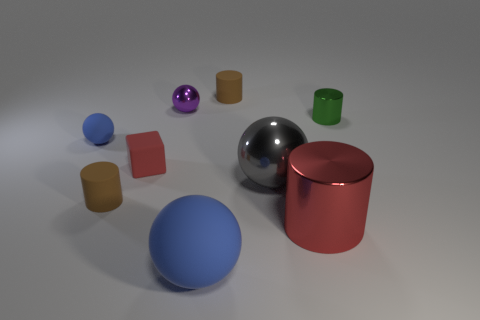Subtract 1 spheres. How many spheres are left? 3 Add 1 tiny yellow rubber spheres. How many objects exist? 10 Subtract all brown spheres. Subtract all brown blocks. How many spheres are left? 4 Subtract all blocks. How many objects are left? 8 Add 4 big blue rubber objects. How many big blue rubber objects exist? 5 Subtract 0 gray cylinders. How many objects are left? 9 Subtract all tiny cyan rubber cylinders. Subtract all small blue matte balls. How many objects are left? 8 Add 9 big shiny cylinders. How many big shiny cylinders are left? 10 